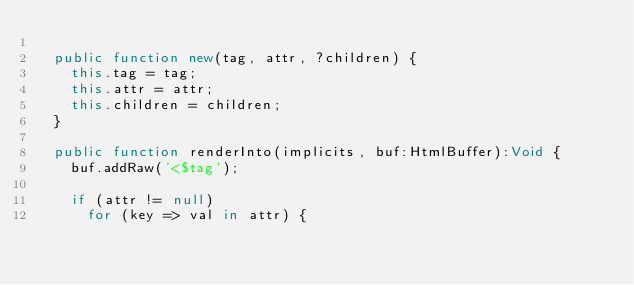Convert code to text. <code><loc_0><loc_0><loc_500><loc_500><_Haxe_>
  public function new(tag, attr, ?children) {
    this.tag = tag;
    this.attr = attr;
    this.children = children;
  }

  public function renderInto(implicits, buf:HtmlBuffer):Void {
    buf.addRaw('<$tag');

    if (attr != null)
      for (key => val in attr) {</code> 